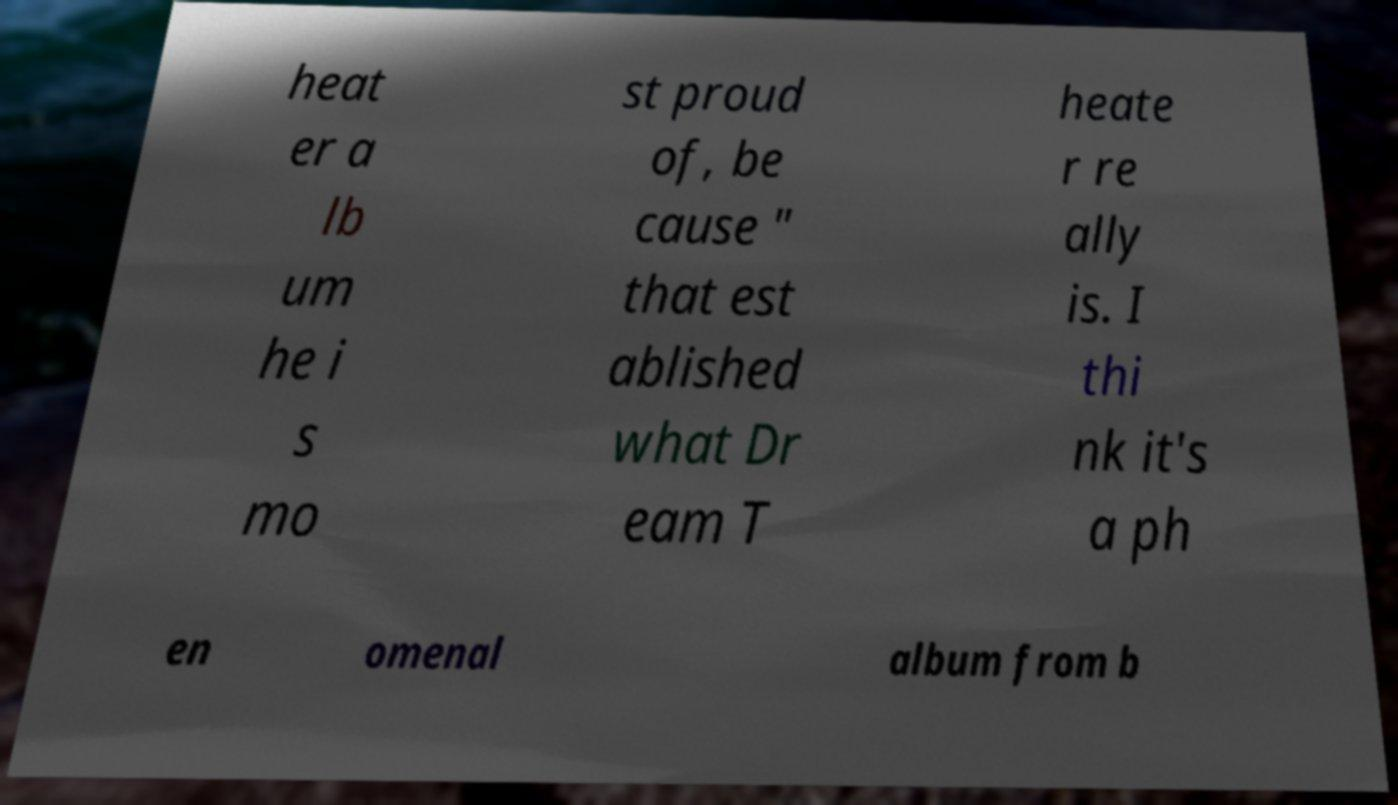Please read and relay the text visible in this image. What does it say? heat er a lb um he i s mo st proud of, be cause " that est ablished what Dr eam T heate r re ally is. I thi nk it's a ph en omenal album from b 